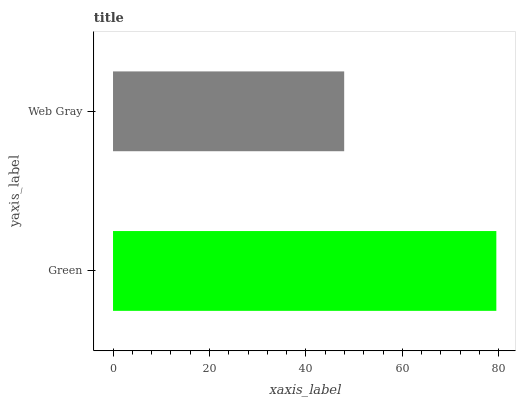Is Web Gray the minimum?
Answer yes or no. Yes. Is Green the maximum?
Answer yes or no. Yes. Is Web Gray the maximum?
Answer yes or no. No. Is Green greater than Web Gray?
Answer yes or no. Yes. Is Web Gray less than Green?
Answer yes or no. Yes. Is Web Gray greater than Green?
Answer yes or no. No. Is Green less than Web Gray?
Answer yes or no. No. Is Green the high median?
Answer yes or no. Yes. Is Web Gray the low median?
Answer yes or no. Yes. Is Web Gray the high median?
Answer yes or no. No. Is Green the low median?
Answer yes or no. No. 